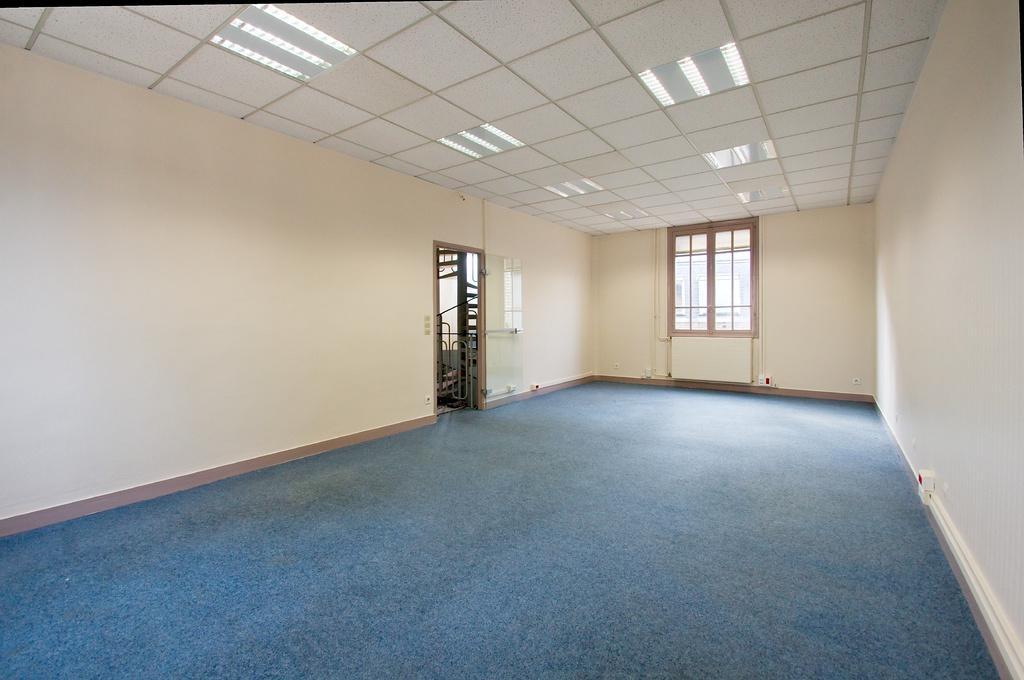Could you give a brief overview of what you see in this image? This is an inside view of a room. In the background there is a window to the wall and also there is a door. At the top there are few lights. 